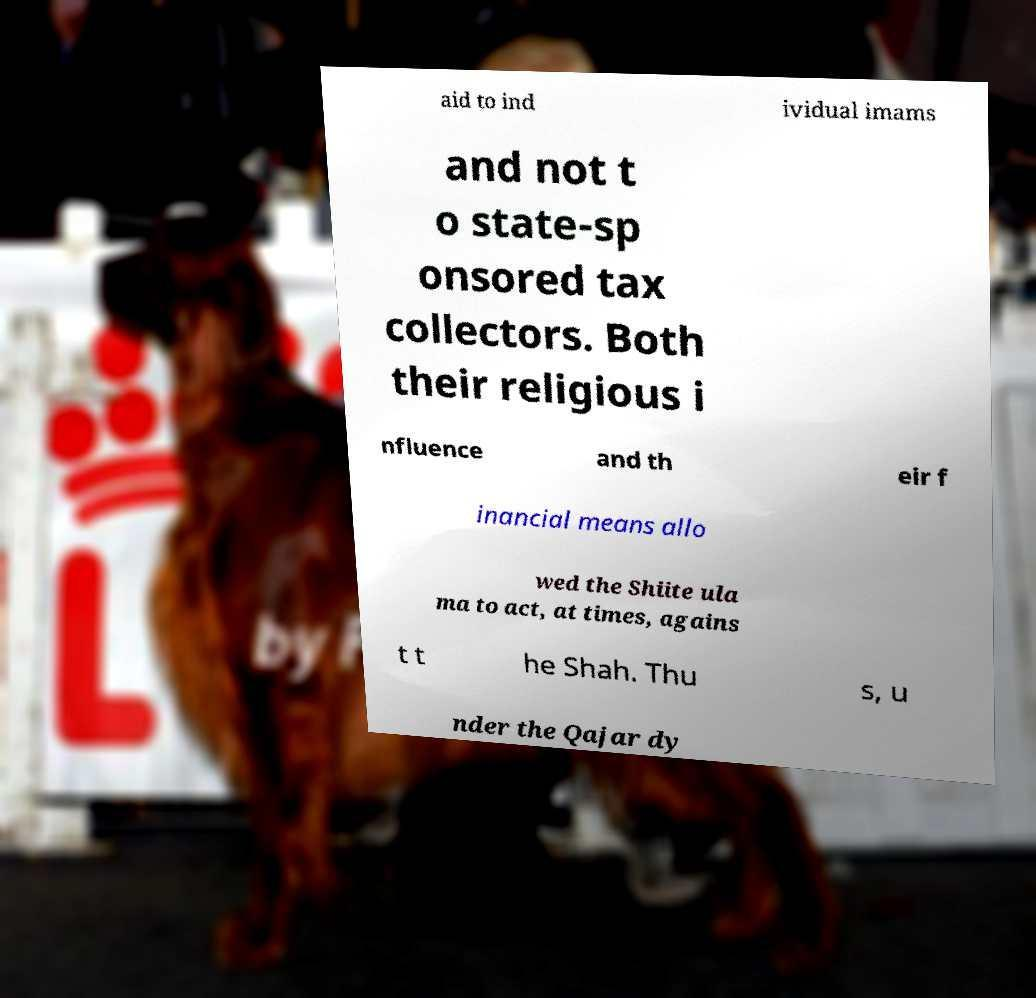Can you read and provide the text displayed in the image?This photo seems to have some interesting text. Can you extract and type it out for me? aid to ind ividual imams and not t o state-sp onsored tax collectors. Both their religious i nfluence and th eir f inancial means allo wed the Shiite ula ma to act, at times, agains t t he Shah. Thu s, u nder the Qajar dy 